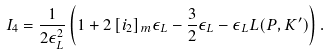Convert formula to latex. <formula><loc_0><loc_0><loc_500><loc_500>I _ { 4 } = \frac { 1 } { 2 \epsilon _ { L } ^ { 2 } } \left ( 1 + 2 \, [ i _ { 2 } ] _ { m } \epsilon _ { L } - \frac { 3 } { 2 } \epsilon _ { L } - \epsilon _ { L } L ( P , K ^ { \prime } ) \right ) .</formula> 